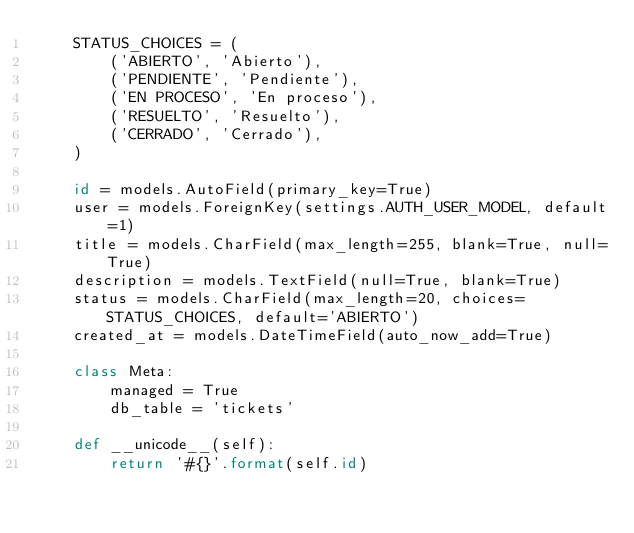Convert code to text. <code><loc_0><loc_0><loc_500><loc_500><_Python_>    STATUS_CHOICES = (
        ('ABIERTO', 'Abierto'),
        ('PENDIENTE', 'Pendiente'),
        ('EN PROCESO', 'En proceso'),
        ('RESUELTO', 'Resuelto'),
        ('CERRADO', 'Cerrado'),
    )

    id = models.AutoField(primary_key=True)
    user = models.ForeignKey(settings.AUTH_USER_MODEL, default=1)
    title = models.CharField(max_length=255, blank=True, null=True)
    description = models.TextField(null=True, blank=True)
    status = models.CharField(max_length=20, choices=STATUS_CHOICES, default='ABIERTO')
    created_at = models.DateTimeField(auto_now_add=True)

    class Meta:
        managed = True
        db_table = 'tickets'

    def __unicode__(self):
        return '#{}'.format(self.id)
</code> 